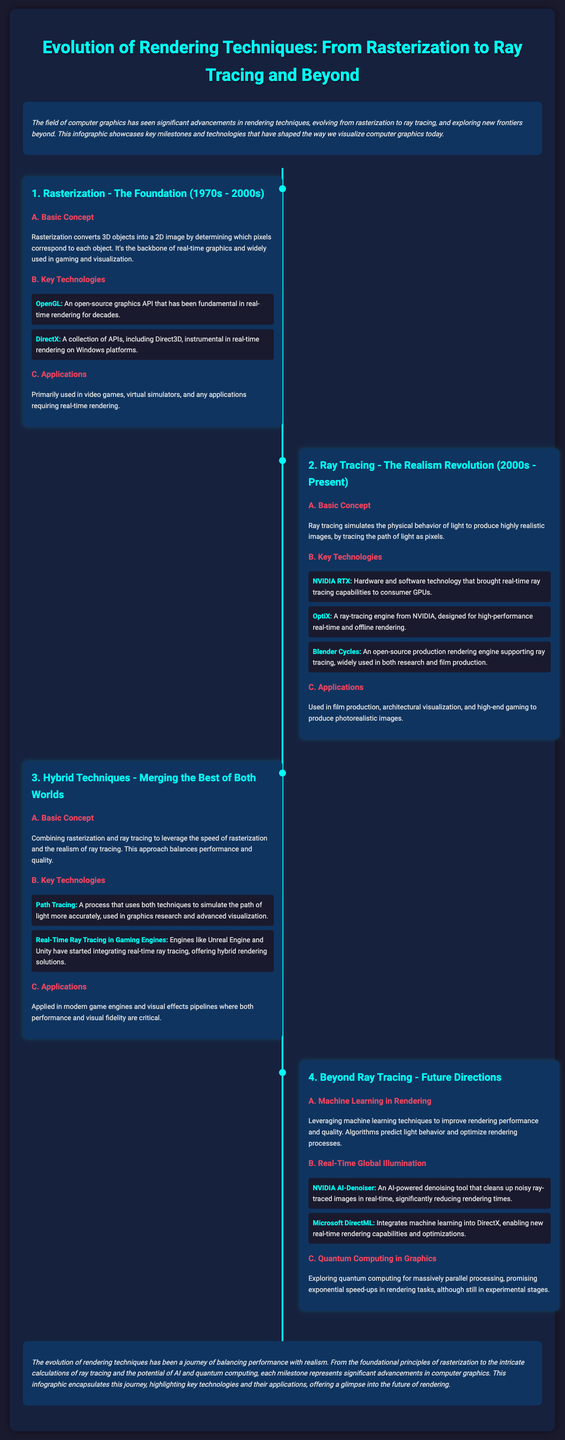What is the primary technique used in the 1970s to 2000s? The document states that rasterization is the primary technique during this period.
Answer: rasterization Which key technology is associated with real-time ray tracing? The document mentions NVIDIA RTX as a key technology for real-time ray tracing capabilities.
Answer: NVIDIA RTX In which applications is rasterization primarily used? According to the document, rasterization is primarily used in video games and virtual simulators.
Answer: video games, virtual simulators What defines the basic concept of hybrid techniques? The document explains that hybrid techniques combine rasterization and ray tracing for a balance of performance and quality.
Answer: combine rasterization and ray tracing Which machine learning tool helps in denoising images? The document lists NVIDIA AI-Denoiser as the tool that aids in denoising noisy ray-traced images in real-time.
Answer: NVIDIA AI-Denoiser What decade marks the beginning of ray tracing? The document specifies the 2000s as the decade when ray tracing began to gain prominence.
Answer: 2000s What type of applications benefit from path tracing? The document notes that path tracing is utilized in graphics research and advanced visualization.
Answer: graphics research, advanced visualization How has the evolution of rendering techniques been characterized? The document summarizes the evolution as a journey of balancing performance with realism.
Answer: balancing performance with realism 